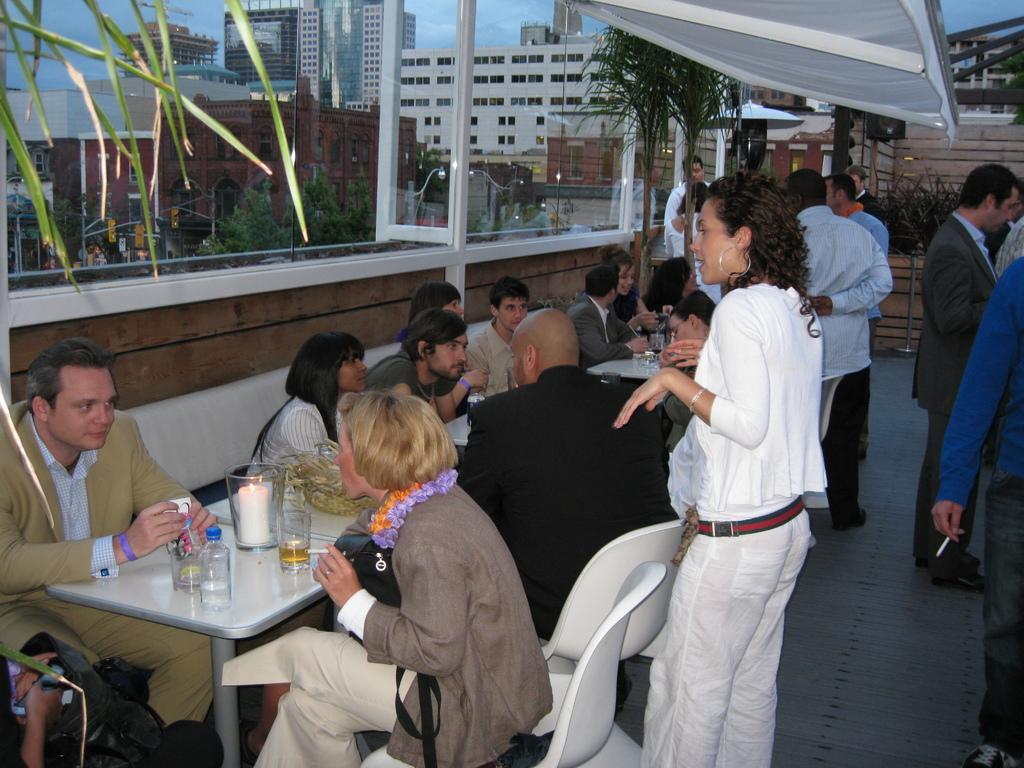In one or two sentences, can you explain what this image depicts? In the picture it looks like a restaurant, there are many people sitting around the tables and on the tables there are glasses, candles and other objects. Beside the tables few people are standing on the floor and in the background there are many buildings and trees. 